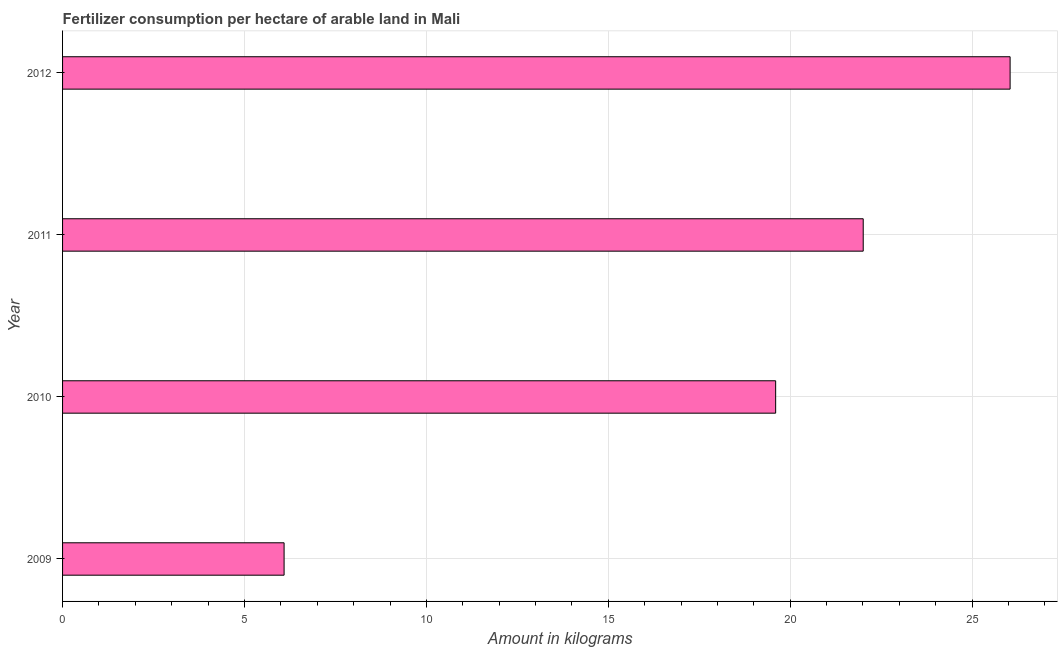Does the graph contain any zero values?
Provide a succinct answer. No. Does the graph contain grids?
Your answer should be very brief. Yes. What is the title of the graph?
Your response must be concise. Fertilizer consumption per hectare of arable land in Mali . What is the label or title of the X-axis?
Offer a terse response. Amount in kilograms. What is the label or title of the Y-axis?
Provide a succinct answer. Year. What is the amount of fertilizer consumption in 2010?
Provide a succinct answer. 19.6. Across all years, what is the maximum amount of fertilizer consumption?
Your answer should be compact. 26.04. Across all years, what is the minimum amount of fertilizer consumption?
Your response must be concise. 6.09. In which year was the amount of fertilizer consumption maximum?
Give a very brief answer. 2012. In which year was the amount of fertilizer consumption minimum?
Offer a very short reply. 2009. What is the sum of the amount of fertilizer consumption?
Ensure brevity in your answer.  73.74. What is the difference between the amount of fertilizer consumption in 2010 and 2011?
Ensure brevity in your answer.  -2.41. What is the average amount of fertilizer consumption per year?
Provide a succinct answer. 18.43. What is the median amount of fertilizer consumption?
Provide a succinct answer. 20.8. In how many years, is the amount of fertilizer consumption greater than 10 kg?
Your response must be concise. 3. What is the ratio of the amount of fertilizer consumption in 2009 to that in 2012?
Your answer should be compact. 0.23. What is the difference between the highest and the second highest amount of fertilizer consumption?
Offer a terse response. 4.04. What is the difference between the highest and the lowest amount of fertilizer consumption?
Your response must be concise. 19.96. In how many years, is the amount of fertilizer consumption greater than the average amount of fertilizer consumption taken over all years?
Provide a succinct answer. 3. How many years are there in the graph?
Give a very brief answer. 4. What is the Amount in kilograms of 2009?
Keep it short and to the point. 6.09. What is the Amount in kilograms of 2010?
Your answer should be very brief. 19.6. What is the Amount in kilograms in 2011?
Keep it short and to the point. 22.01. What is the Amount in kilograms in 2012?
Provide a succinct answer. 26.04. What is the difference between the Amount in kilograms in 2009 and 2010?
Offer a very short reply. -13.51. What is the difference between the Amount in kilograms in 2009 and 2011?
Your response must be concise. -15.92. What is the difference between the Amount in kilograms in 2009 and 2012?
Your answer should be very brief. -19.96. What is the difference between the Amount in kilograms in 2010 and 2011?
Provide a short and direct response. -2.41. What is the difference between the Amount in kilograms in 2010 and 2012?
Make the answer very short. -6.44. What is the difference between the Amount in kilograms in 2011 and 2012?
Provide a short and direct response. -4.04. What is the ratio of the Amount in kilograms in 2009 to that in 2010?
Make the answer very short. 0.31. What is the ratio of the Amount in kilograms in 2009 to that in 2011?
Give a very brief answer. 0.28. What is the ratio of the Amount in kilograms in 2009 to that in 2012?
Provide a short and direct response. 0.23. What is the ratio of the Amount in kilograms in 2010 to that in 2011?
Your answer should be compact. 0.89. What is the ratio of the Amount in kilograms in 2010 to that in 2012?
Your answer should be compact. 0.75. What is the ratio of the Amount in kilograms in 2011 to that in 2012?
Provide a succinct answer. 0.84. 